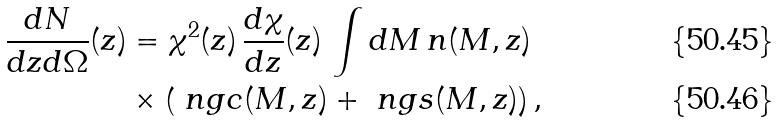<formula> <loc_0><loc_0><loc_500><loc_500>\frac { d N } { d z d \Omega } ( z ) & = \chi ^ { 2 } ( z ) \, \frac { d \chi } { d z } ( z ) \, \int d M \, n ( M , z ) \\ & \times \left ( \ n g c ( M , z ) + \ n g s ( M , z ) \right ) ,</formula> 